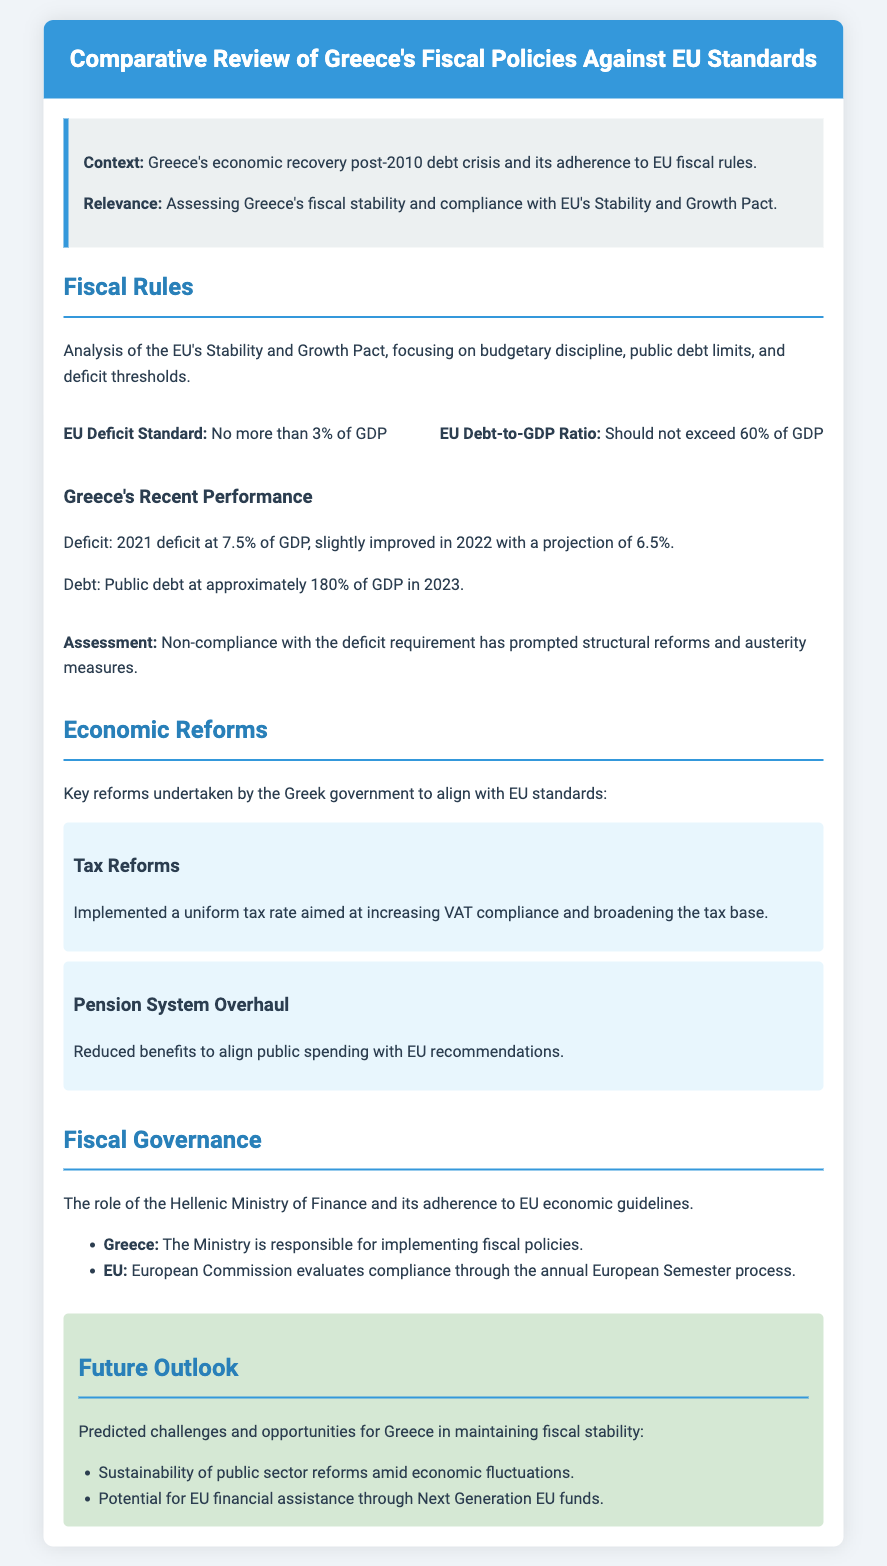What is the EU Deficit Standard? The EU Deficit Standard states that member states should have a deficit of no more than 3% of GDP.
Answer: 3% of GDP What was Greece's public debt in 2023? Greece's public debt is stated to be approximately 180% of GDP in 2023.
Answer: 180% of GDP What key reform relates to tax changes? The key reform related to tax changes is the implementation of a uniform tax rate aimed at increasing VAT compliance.
Answer: Uniform tax rate What was Greece's deficit in 2021? The document specifies Greece's deficit in 2021 as 7.5% of GDP.
Answer: 7.5% of GDP What role does the European Commission play in Greece's fiscal governance? The European Commission evaluates compliance through the annual European Semester process.
Answer: Evaluates compliance What challenge is predicted for Greece's future outlook? The document mentions sustainability of public sector reforms amid economic fluctuations as a predicted challenge.
Answer: Sustainability of public sector reforms Which structural reform relates to pensions? The structural reform relating to pensions is a pension system overhaul that reduced benefits.
Answer: Pension system overhaul What is the main focus of the EU's Stability and Growth Pact? The main focus of the EU's Stability and Growth Pact is budgetary discipline, public debt limits, and deficit thresholds.
Answer: Budgetary discipline What was Greece's projected deficit in 2022? The projected deficit for Greece in 2022 was 6.5% of GDP.
Answer: 6.5% of GDP 